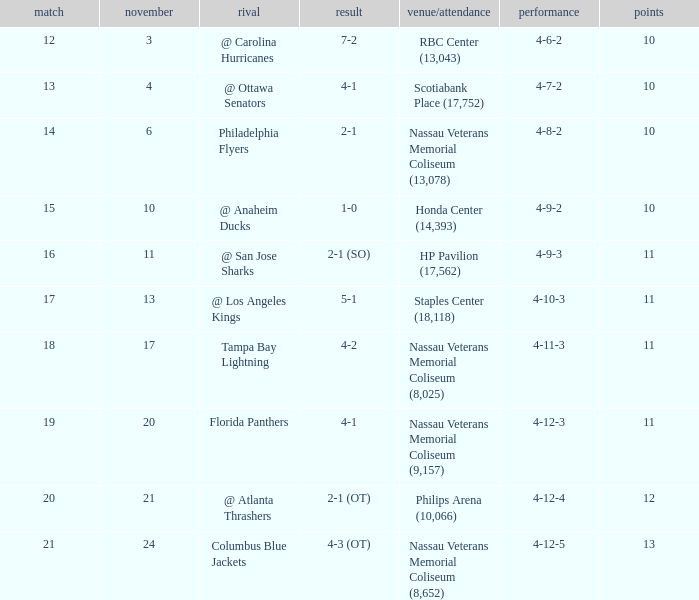What is every record for game 13? 4-7-2. 